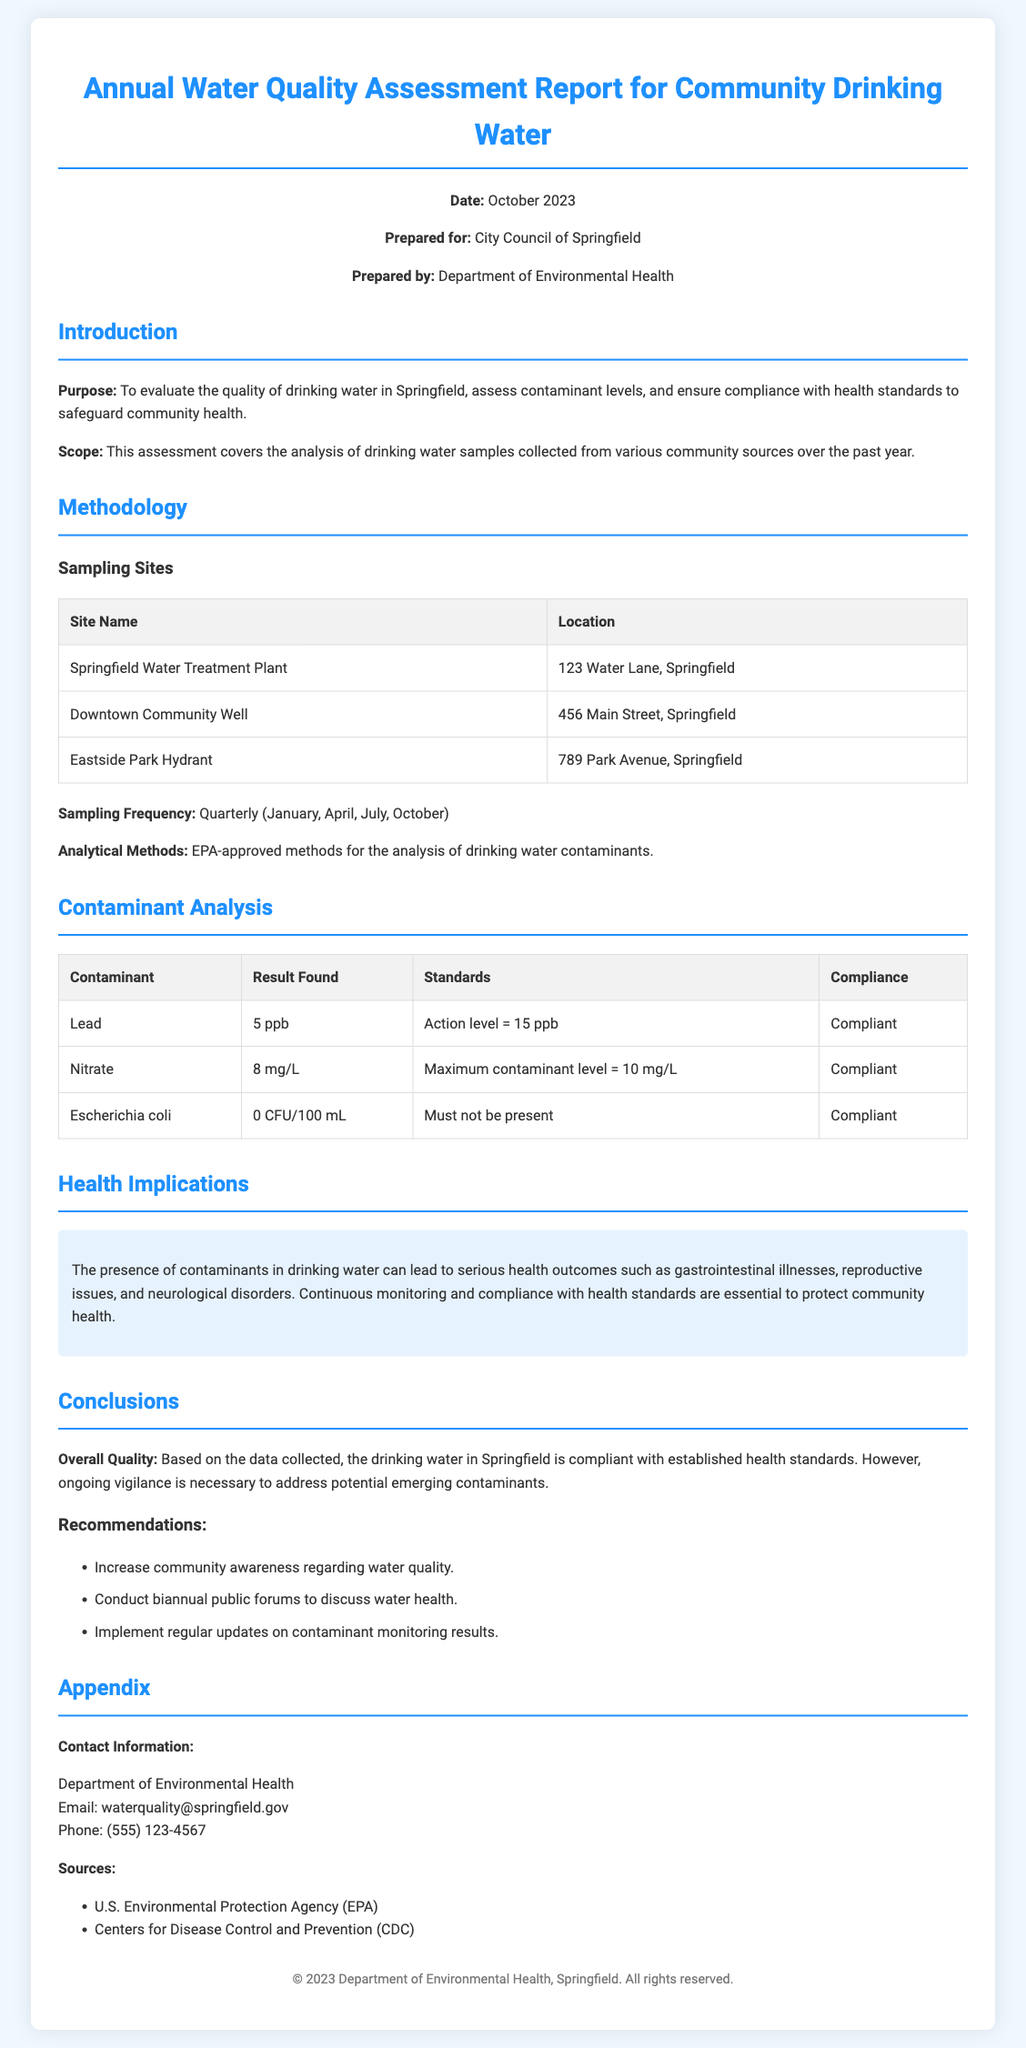What is the date of the report? The report is dated October 2023, as stated in the header section.
Answer: October 2023 Who prepared the report? The document specifies that it was prepared by the Department of Environmental Health.
Answer: Department of Environmental Health What is the sampling frequency for the water quality assessment? The report states that the sampling frequency is quarterly (January, April, July, October).
Answer: Quarterly What contaminant was found at 5 ppb? The table shows that lead was found at 5 ppb in the contaminant analysis section.
Answer: Lead What is the maximum contaminant level for nitrate? The report indicates that the maximum contaminant level for nitrate is 10 mg/L.
Answer: 10 mg/L What is noted as a serious health outcome due to contaminants in drinking water? The document highlights gastrointestinal illnesses as a serious health outcome.
Answer: Gastrointestinal illnesses What action is recommended for increasing community awareness? The recommendations suggest increasing community awareness regarding water quality.
Answer: Increase community awareness Is E. coli present in the water samples? The contaminant analysis table indicates that E. coli was found at 0 CFU/100 mL, meaning it must not be present.
Answer: 0 CFU/100 mL What is the overall conclusion regarding the water quality? The report concludes that the drinking water is compliant with established health standards.
Answer: Compliant with established health standards 